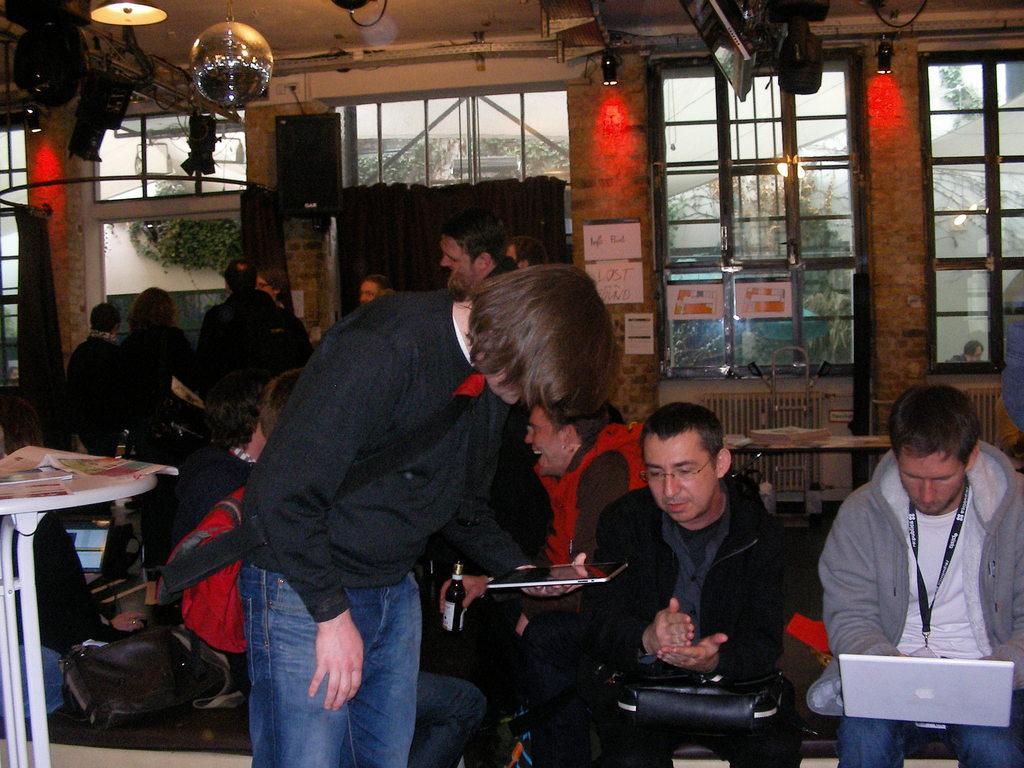Describe this image in one or two sentences. In this image I see lot of people in which few of them are sitting and most of them are standing. I can also see that there are lights and windows on the wall. 